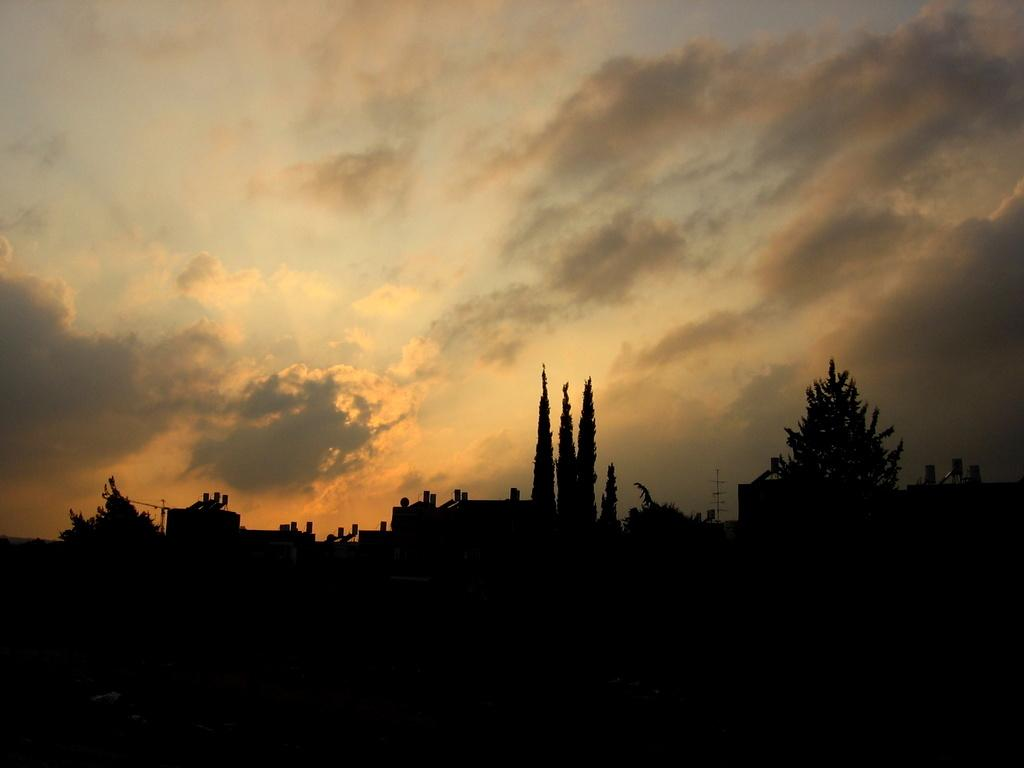What type of vegetation can be seen in the image? There are trees in the image. What type of structure is present in the image? There is a building in the image. How would you describe the lighting in the image? The image appears to be dark. What can be seen in the background of the image? The sky is visible in the background of the image. What is the condition of the sky in the image? The sky is cloudy in the image. How many tomatoes are hanging from the trees in the image? There are no tomatoes present in the image; it features trees and a building. What type of stick can be seen leaning against the building in the image? There is no stick present in the image; it only features trees, a building, and a cloudy sky. 